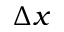<formula> <loc_0><loc_0><loc_500><loc_500>\Delta x</formula> 